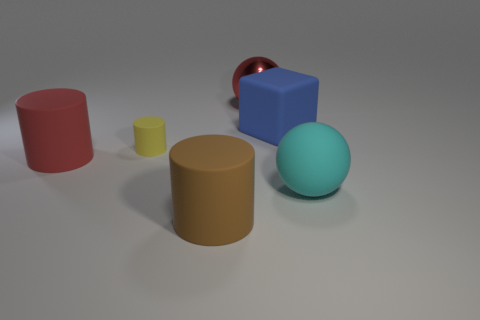Subtract all large matte cylinders. How many cylinders are left? 1 Subtract all red balls. How many balls are left? 1 Add 1 red rubber things. How many objects exist? 7 Subtract 2 spheres. How many spheres are left? 0 Subtract all blocks. How many objects are left? 5 Subtract all red cylinders. How many gray spheres are left? 0 Subtract all brown matte things. Subtract all large matte balls. How many objects are left? 4 Add 6 balls. How many balls are left? 8 Add 6 tiny rubber cylinders. How many tiny rubber cylinders exist? 7 Subtract 0 gray cubes. How many objects are left? 6 